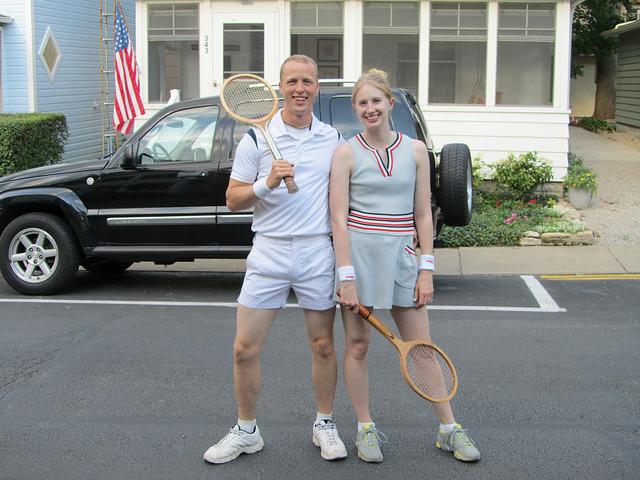Are they arguing?
Give a very brief answer. No. What country's flag is in front of the house?
Give a very brief answer. Usa. What is this person holding?
Give a very brief answer. Tennis racket. Is this a bus stop?
Be succinct. No. Are they related?
Write a very short answer. Yes. 